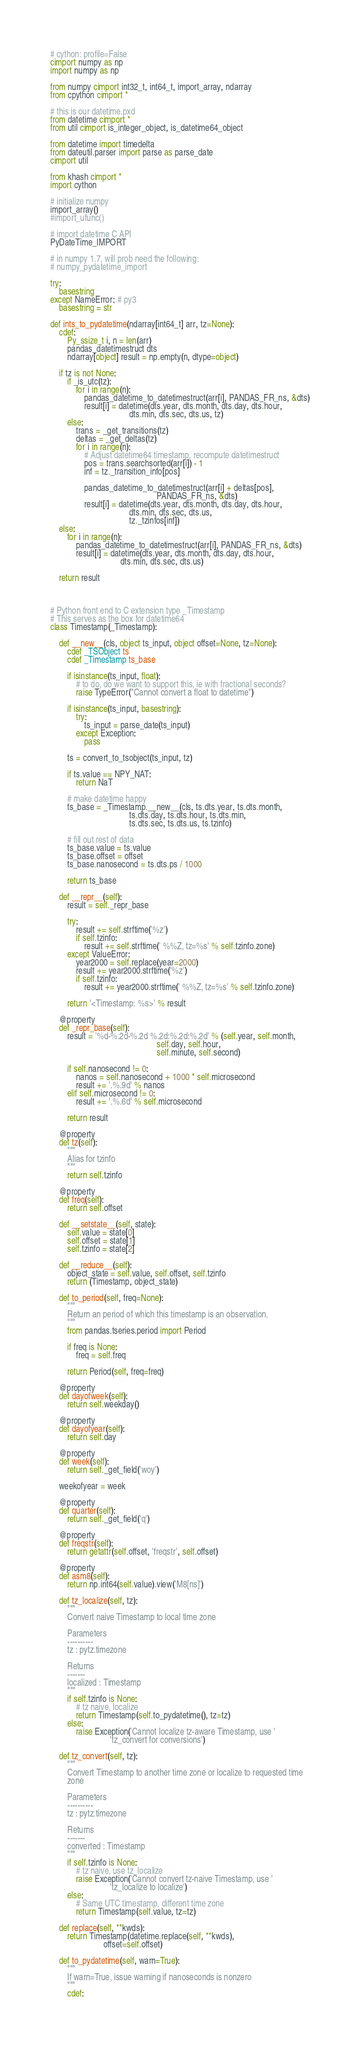Convert code to text. <code><loc_0><loc_0><loc_500><loc_500><_Cython_># cython: profile=False
cimport numpy as np
import numpy as np

from numpy cimport int32_t, int64_t, import_array, ndarray
from cpython cimport *

# this is our datetime.pxd
from datetime cimport *
from util cimport is_integer_object, is_datetime64_object

from datetime import timedelta
from dateutil.parser import parse as parse_date
cimport util

from khash cimport *
import cython

# initialize numpy
import_array()
#import_ufunc()

# import datetime C API
PyDateTime_IMPORT

# in numpy 1.7, will prob need the following:
# numpy_pydatetime_import

try:
    basestring
except NameError: # py3
    basestring = str

def ints_to_pydatetime(ndarray[int64_t] arr, tz=None):
    cdef:
        Py_ssize_t i, n = len(arr)
        pandas_datetimestruct dts
        ndarray[object] result = np.empty(n, dtype=object)

    if tz is not None:
        if _is_utc(tz):
            for i in range(n):
                pandas_datetime_to_datetimestruct(arr[i], PANDAS_FR_ns, &dts)
                result[i] = datetime(dts.year, dts.month, dts.day, dts.hour,
                                     dts.min, dts.sec, dts.us, tz)
        else:
            trans = _get_transitions(tz)
            deltas = _get_deltas(tz)
            for i in range(n):
                # Adjust datetime64 timestamp, recompute datetimestruct
                pos = trans.searchsorted(arr[i]) - 1
                inf = tz._transition_info[pos]

                pandas_datetime_to_datetimestruct(arr[i] + deltas[pos],
                                                  PANDAS_FR_ns, &dts)
                result[i] = datetime(dts.year, dts.month, dts.day, dts.hour,
                                     dts.min, dts.sec, dts.us,
                                     tz._tzinfos[inf])
    else:
        for i in range(n):
            pandas_datetime_to_datetimestruct(arr[i], PANDAS_FR_ns, &dts)
            result[i] = datetime(dts.year, dts.month, dts.day, dts.hour,
                                 dts.min, dts.sec, dts.us)

    return result



# Python front end to C extension type _Timestamp
# This serves as the box for datetime64
class Timestamp(_Timestamp):

    def __new__(cls, object ts_input, object offset=None, tz=None):
        cdef _TSObject ts
        cdef _Timestamp ts_base

        if isinstance(ts_input, float):
            # to do, do we want to support this, ie with fractional seconds?
            raise TypeError("Cannot convert a float to datetime")

        if isinstance(ts_input, basestring):
            try:
                ts_input = parse_date(ts_input)
            except Exception:
                pass

        ts = convert_to_tsobject(ts_input, tz)

        if ts.value == NPY_NAT:
            return NaT

        # make datetime happy
        ts_base = _Timestamp.__new__(cls, ts.dts.year, ts.dts.month,
                                     ts.dts.day, ts.dts.hour, ts.dts.min,
                                     ts.dts.sec, ts.dts.us, ts.tzinfo)

        # fill out rest of data
        ts_base.value = ts.value
        ts_base.offset = offset
        ts_base.nanosecond = ts.dts.ps / 1000

        return ts_base

    def __repr__(self):
        result = self._repr_base

        try:
            result += self.strftime('%z')
            if self.tzinfo:
                result += self.strftime(' %%Z, tz=%s' % self.tzinfo.zone)
        except ValueError:
            year2000 = self.replace(year=2000)
            result += year2000.strftime('%z')
            if self.tzinfo:
                result += year2000.strftime(' %%Z, tz=%s' % self.tzinfo.zone)

        return '<Timestamp: %s>' % result

    @property
    def _repr_base(self):
        result = '%d-%.2d-%.2d %.2d:%.2d:%.2d' % (self.year, self.month,
                                                  self.day, self.hour,
                                                  self.minute, self.second)

        if self.nanosecond != 0:
            nanos = self.nanosecond + 1000 * self.microsecond
            result += '.%.9d' % nanos
        elif self.microsecond != 0:
            result += '.%.6d' % self.microsecond

        return result

    @property
    def tz(self):
        """
        Alias for tzinfo
        """
        return self.tzinfo

    @property
    def freq(self):
        return self.offset

    def __setstate__(self, state):
        self.value = state[0]
        self.offset = state[1]
        self.tzinfo = state[2]

    def __reduce__(self):
        object_state = self.value, self.offset, self.tzinfo
        return (Timestamp, object_state)

    def to_period(self, freq=None):
        """
        Return an period of which this timestamp is an observation.
        """
        from pandas.tseries.period import Period

        if freq is None:
            freq = self.freq

        return Period(self, freq=freq)

    @property
    def dayofweek(self):
        return self.weekday()

    @property
    def dayofyear(self):
        return self.day

    @property
    def week(self):
        return self._get_field('woy')

    weekofyear = week

    @property
    def quarter(self):
        return self._get_field('q')

    @property
    def freqstr(self):
        return getattr(self.offset, 'freqstr', self.offset)

    @property
    def asm8(self):
        return np.int64(self.value).view('M8[ns]')

    def tz_localize(self, tz):
        """
        Convert naive Timestamp to local time zone

        Parameters
        ----------
        tz : pytz.timezone

        Returns
        -------
        localized : Timestamp
        """
        if self.tzinfo is None:
            # tz naive, localize
            return Timestamp(self.to_pydatetime(), tz=tz)
        else:
            raise Exception('Cannot localize tz-aware Timestamp, use '
                            'tz_convert for conversions')

    def tz_convert(self, tz):
        """
        Convert Timestamp to another time zone or localize to requested time
        zone

        Parameters
        ----------
        tz : pytz.timezone

        Returns
        -------
        converted : Timestamp
        """
        if self.tzinfo is None:
            # tz naive, use tz_localize
            raise Exception('Cannot convert tz-naive Timestamp, use '
                            'tz_localize to localize')
        else:
            # Same UTC timestamp, different time zone
            return Timestamp(self.value, tz=tz)

    def replace(self, **kwds):
        return Timestamp(datetime.replace(self, **kwds),
                         offset=self.offset)

    def to_pydatetime(self, warn=True):
        """
        If warn=True, issue warning if nanoseconds is nonzero
        """
        cdef:</code> 